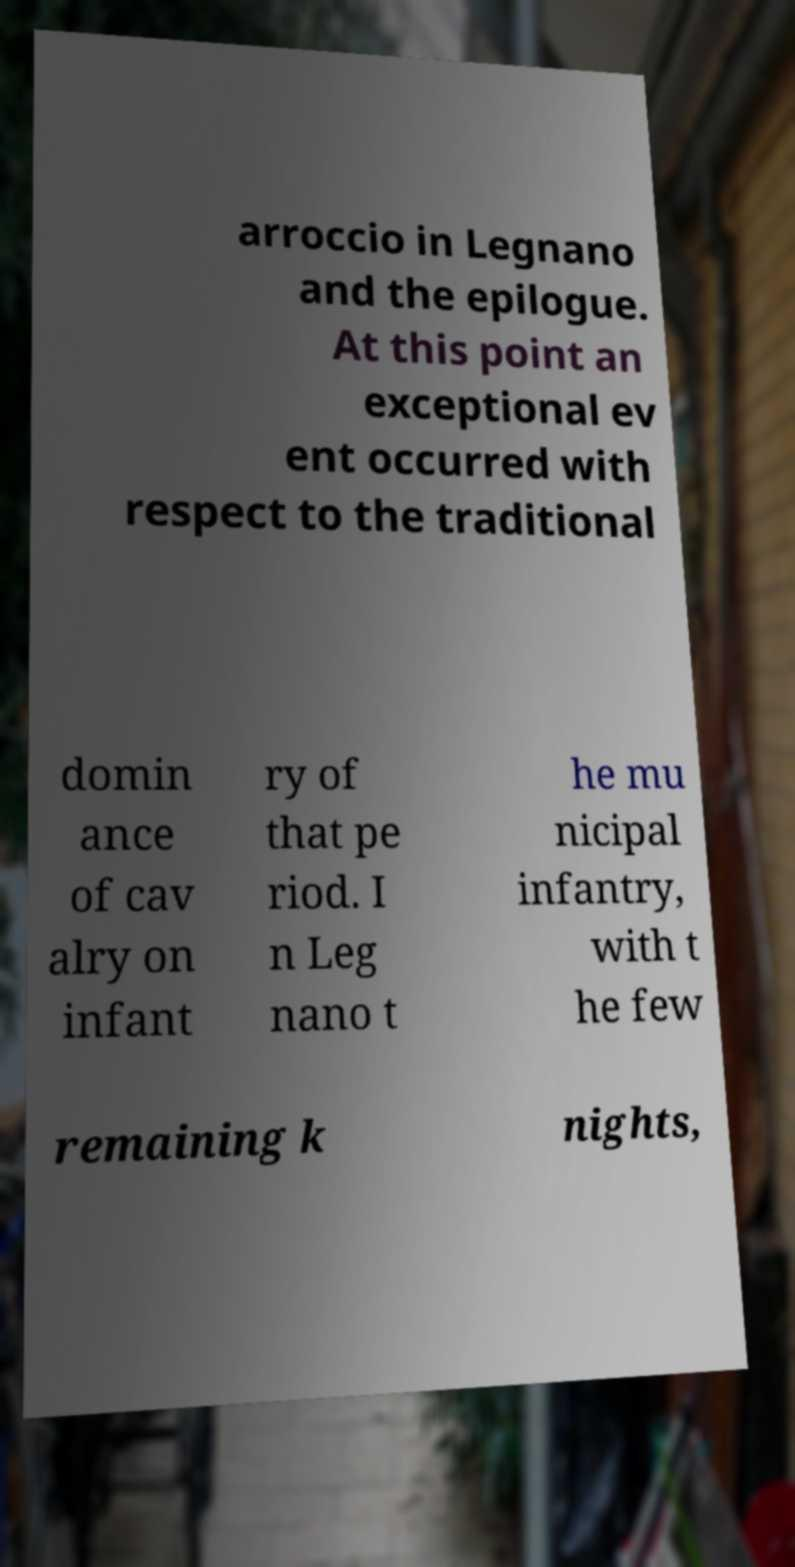Could you assist in decoding the text presented in this image and type it out clearly? arroccio in Legnano and the epilogue. At this point an exceptional ev ent occurred with respect to the traditional domin ance of cav alry on infant ry of that pe riod. I n Leg nano t he mu nicipal infantry, with t he few remaining k nights, 